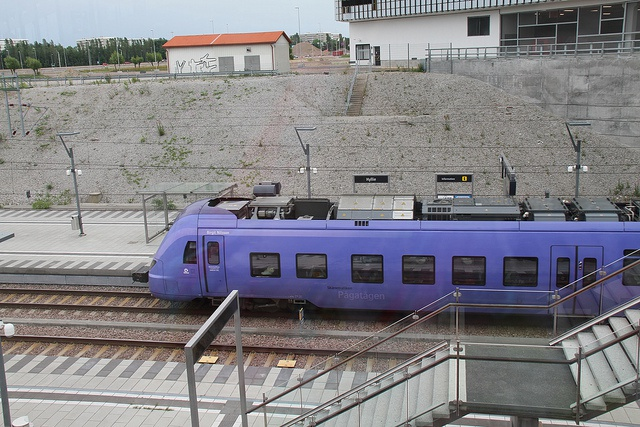Describe the objects in this image and their specific colors. I can see a train in lightgray, blue, black, gray, and violet tones in this image. 